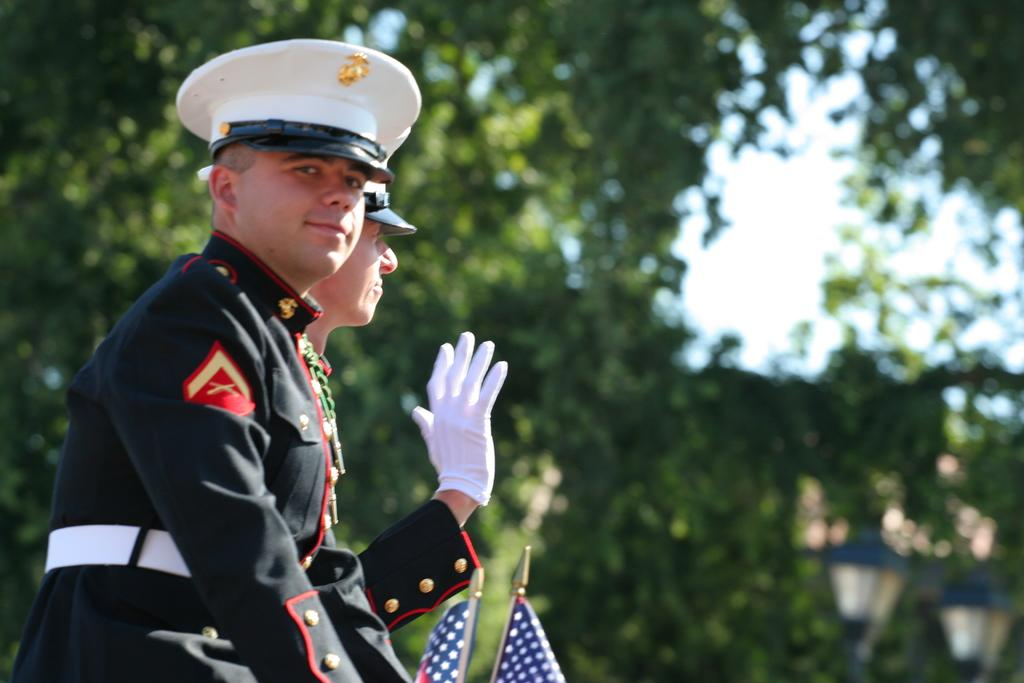How many people are present in the image? There are two people standing in the image. What type of vegetation can be seen in the image? There are green trees in the image. How many flags are visible in the image? There are two flags in the image. How many lights are present in the image? There are two lights in the image. What is visible in the background of the image? The sky is visible in the image. What type of silk is being discussed in the meeting depicted in the image? There is no meeting or discussion of silk present in the image. What beliefs are shared by the people in the image? There is no information about the beliefs of the people in the image. 